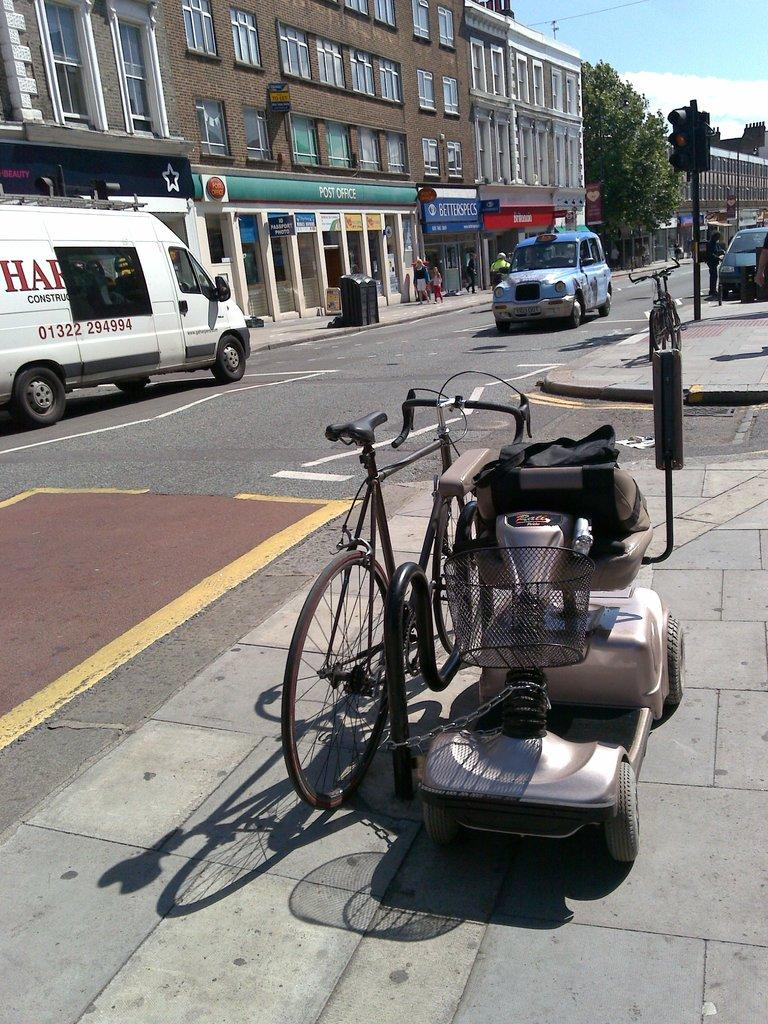<image>
Give a short and clear explanation of the subsequent image. A road outside a post office has cars driving on it. 